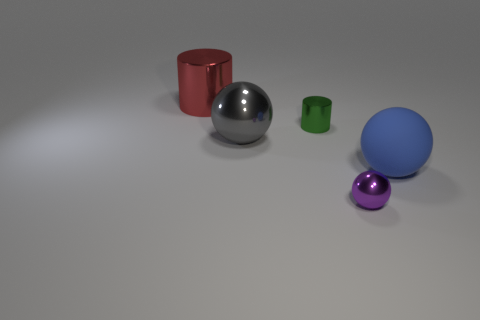How big is the thing in front of the blue thing?
Offer a terse response. Small. What material is the purple thing?
Make the answer very short. Metal. What number of things are either spheres that are in front of the blue ball or tiny objects to the right of the small green metallic cylinder?
Offer a very short reply. 1. What number of other things are there of the same color as the matte sphere?
Ensure brevity in your answer.  0. Does the red metal thing have the same shape as the small shiny object in front of the matte sphere?
Ensure brevity in your answer.  No. Are there fewer small metallic cylinders that are to the left of the big gray shiny thing than large matte spheres in front of the large blue sphere?
Your response must be concise. No. What material is the gray object that is the same shape as the small purple shiny thing?
Your answer should be very brief. Metal. Are there any other things that have the same material as the green cylinder?
Give a very brief answer. Yes. Does the tiny metal cylinder have the same color as the matte thing?
Provide a short and direct response. No. There is a large gray object that is the same material as the small green object; what shape is it?
Your answer should be compact. Sphere. 